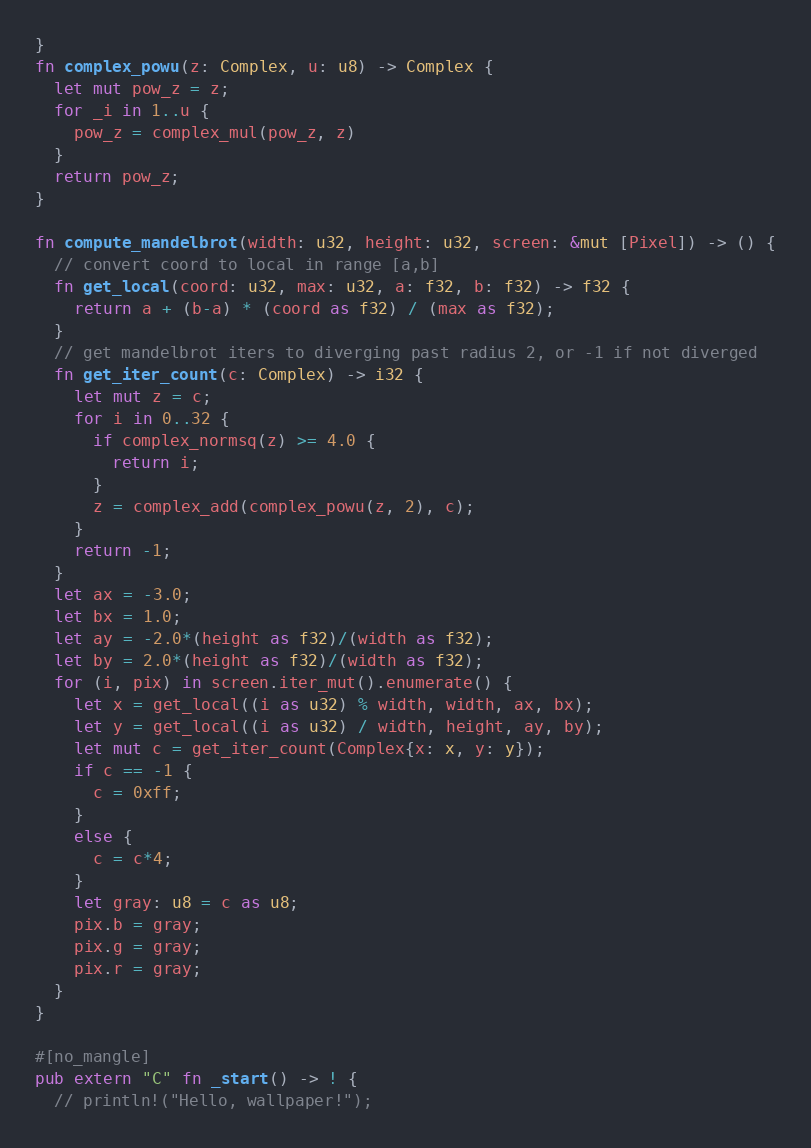<code> <loc_0><loc_0><loc_500><loc_500><_Rust_>}
fn complex_powu(z: Complex, u: u8) -> Complex {
  let mut pow_z = z;
  for _i in 1..u {
    pow_z = complex_mul(pow_z, z)
  }
  return pow_z;
}

fn compute_mandelbrot(width: u32, height: u32, screen: &mut [Pixel]) -> () {
  // convert coord to local in range [a,b]
  fn get_local(coord: u32, max: u32, a: f32, b: f32) -> f32 {
    return a + (b-a) * (coord as f32) / (max as f32);
  }
  // get mandelbrot iters to diverging past radius 2, or -1 if not diverged
  fn get_iter_count(c: Complex) -> i32 {
    let mut z = c;
    for i in 0..32 {
      if complex_normsq(z) >= 4.0 {
        return i;
      }
      z = complex_add(complex_powu(z, 2), c);
    }
    return -1;
  }
  let ax = -3.0;
  let bx = 1.0;
  let ay = -2.0*(height as f32)/(width as f32);
  let by = 2.0*(height as f32)/(width as f32);
  for (i, pix) in screen.iter_mut().enumerate() {
    let x = get_local((i as u32) % width, width, ax, bx);
    let y = get_local((i as u32) / width, height, ay, by);
    let mut c = get_iter_count(Complex{x: x, y: y});
    if c == -1 {
      c = 0xff;
    }
    else {
      c = c*4;
    }
    let gray: u8 = c as u8;
    pix.b = gray;
    pix.g = gray;
    pix.r = gray;
  }
}

#[no_mangle]
pub extern "C" fn _start() -> ! {
  // println!("Hello, wallpaper!");
</code> 